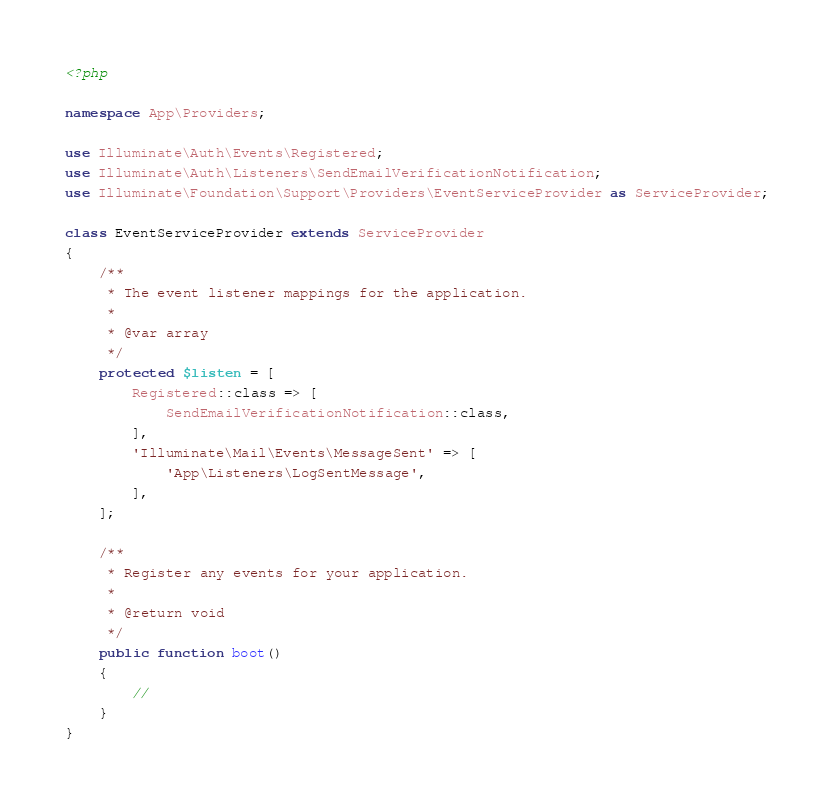Convert code to text. <code><loc_0><loc_0><loc_500><loc_500><_PHP_><?php

namespace App\Providers;

use Illuminate\Auth\Events\Registered;
use Illuminate\Auth\Listeners\SendEmailVerificationNotification;
use Illuminate\Foundation\Support\Providers\EventServiceProvider as ServiceProvider;

class EventServiceProvider extends ServiceProvider
{
    /**
     * The event listener mappings for the application.
     *
     * @var array
     */
    protected $listen = [
        Registered::class => [
            SendEmailVerificationNotification::class,
        ],
        'Illuminate\Mail\Events\MessageSent' => [
            'App\Listeners\LogSentMessage',
        ],
    ];

    /**
     * Register any events for your application.
     *
     * @return void
     */
    public function boot()
    {
        //
    }
}
</code> 